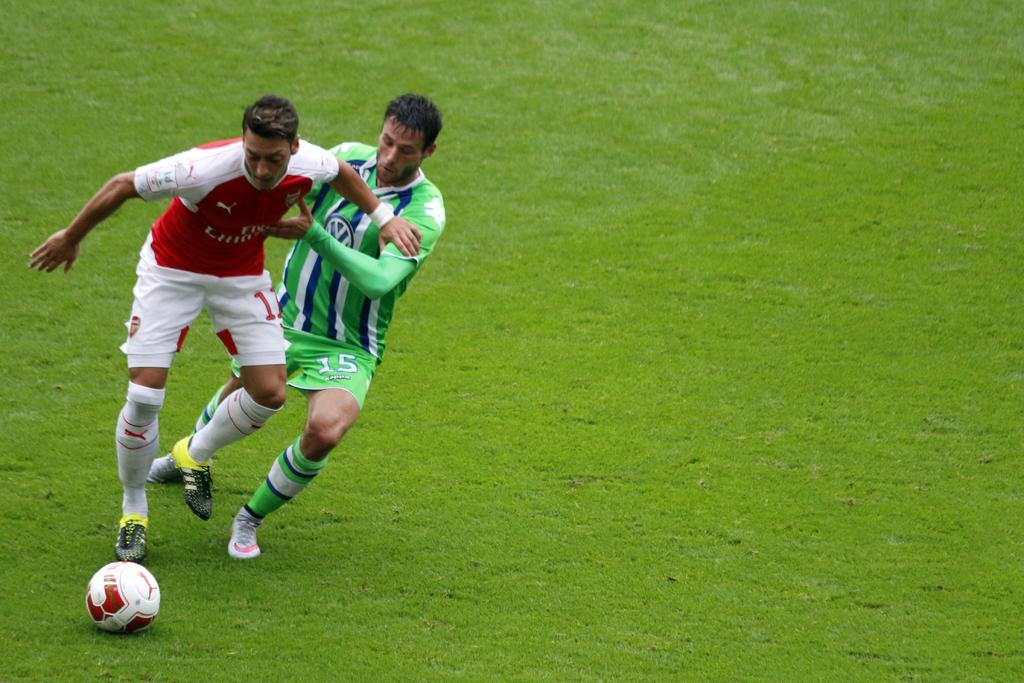How many people are in the image? There are two persons in the image. What are the persons doing in the image? The persons are playing football. What object is being used in the game? There is a football in the image. What type of surface is visible at the bottom of the image? There is grass at the bottom of the image. Whose birthday is being celebrated in the image? There is no indication of a birthday celebration in the image; it features two people playing football on a grassy surface. 